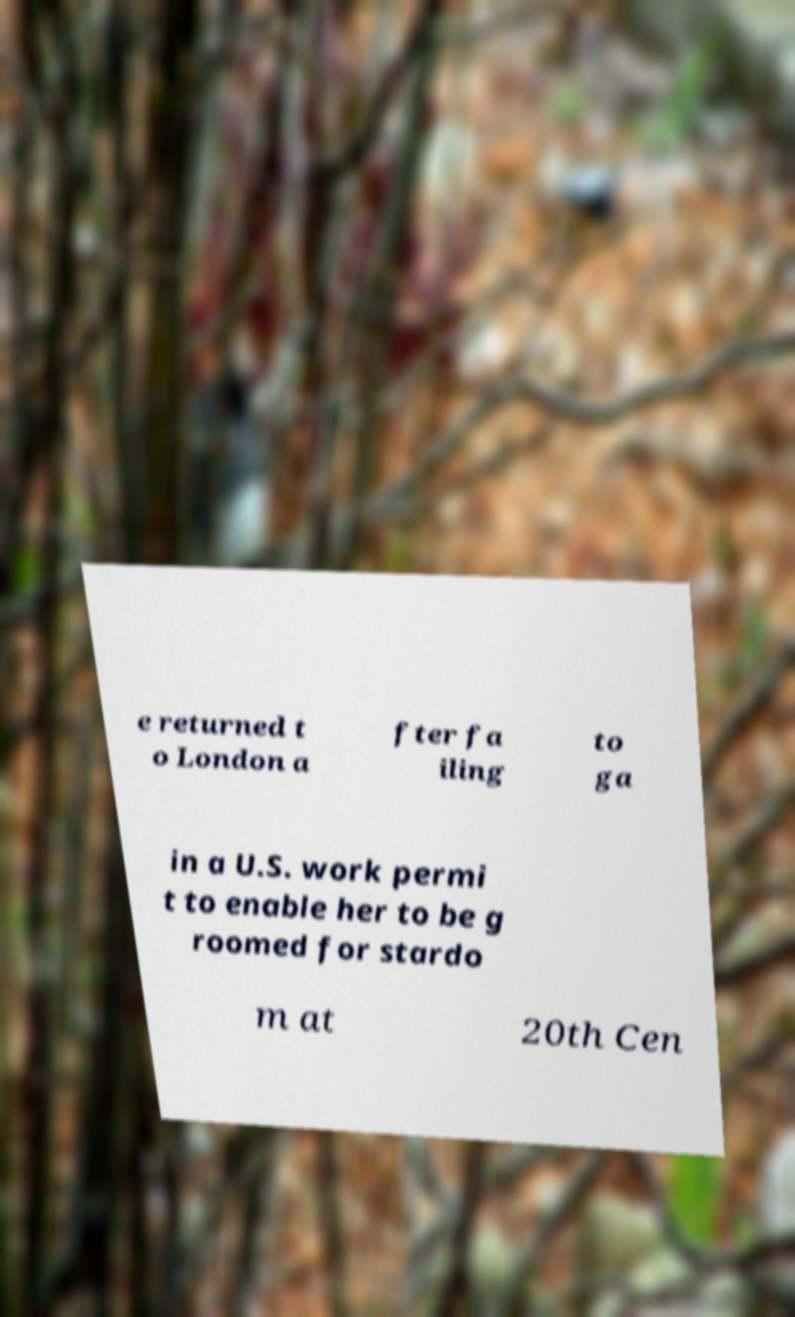Please read and relay the text visible in this image. What does it say? e returned t o London a fter fa iling to ga in a U.S. work permi t to enable her to be g roomed for stardo m at 20th Cen 